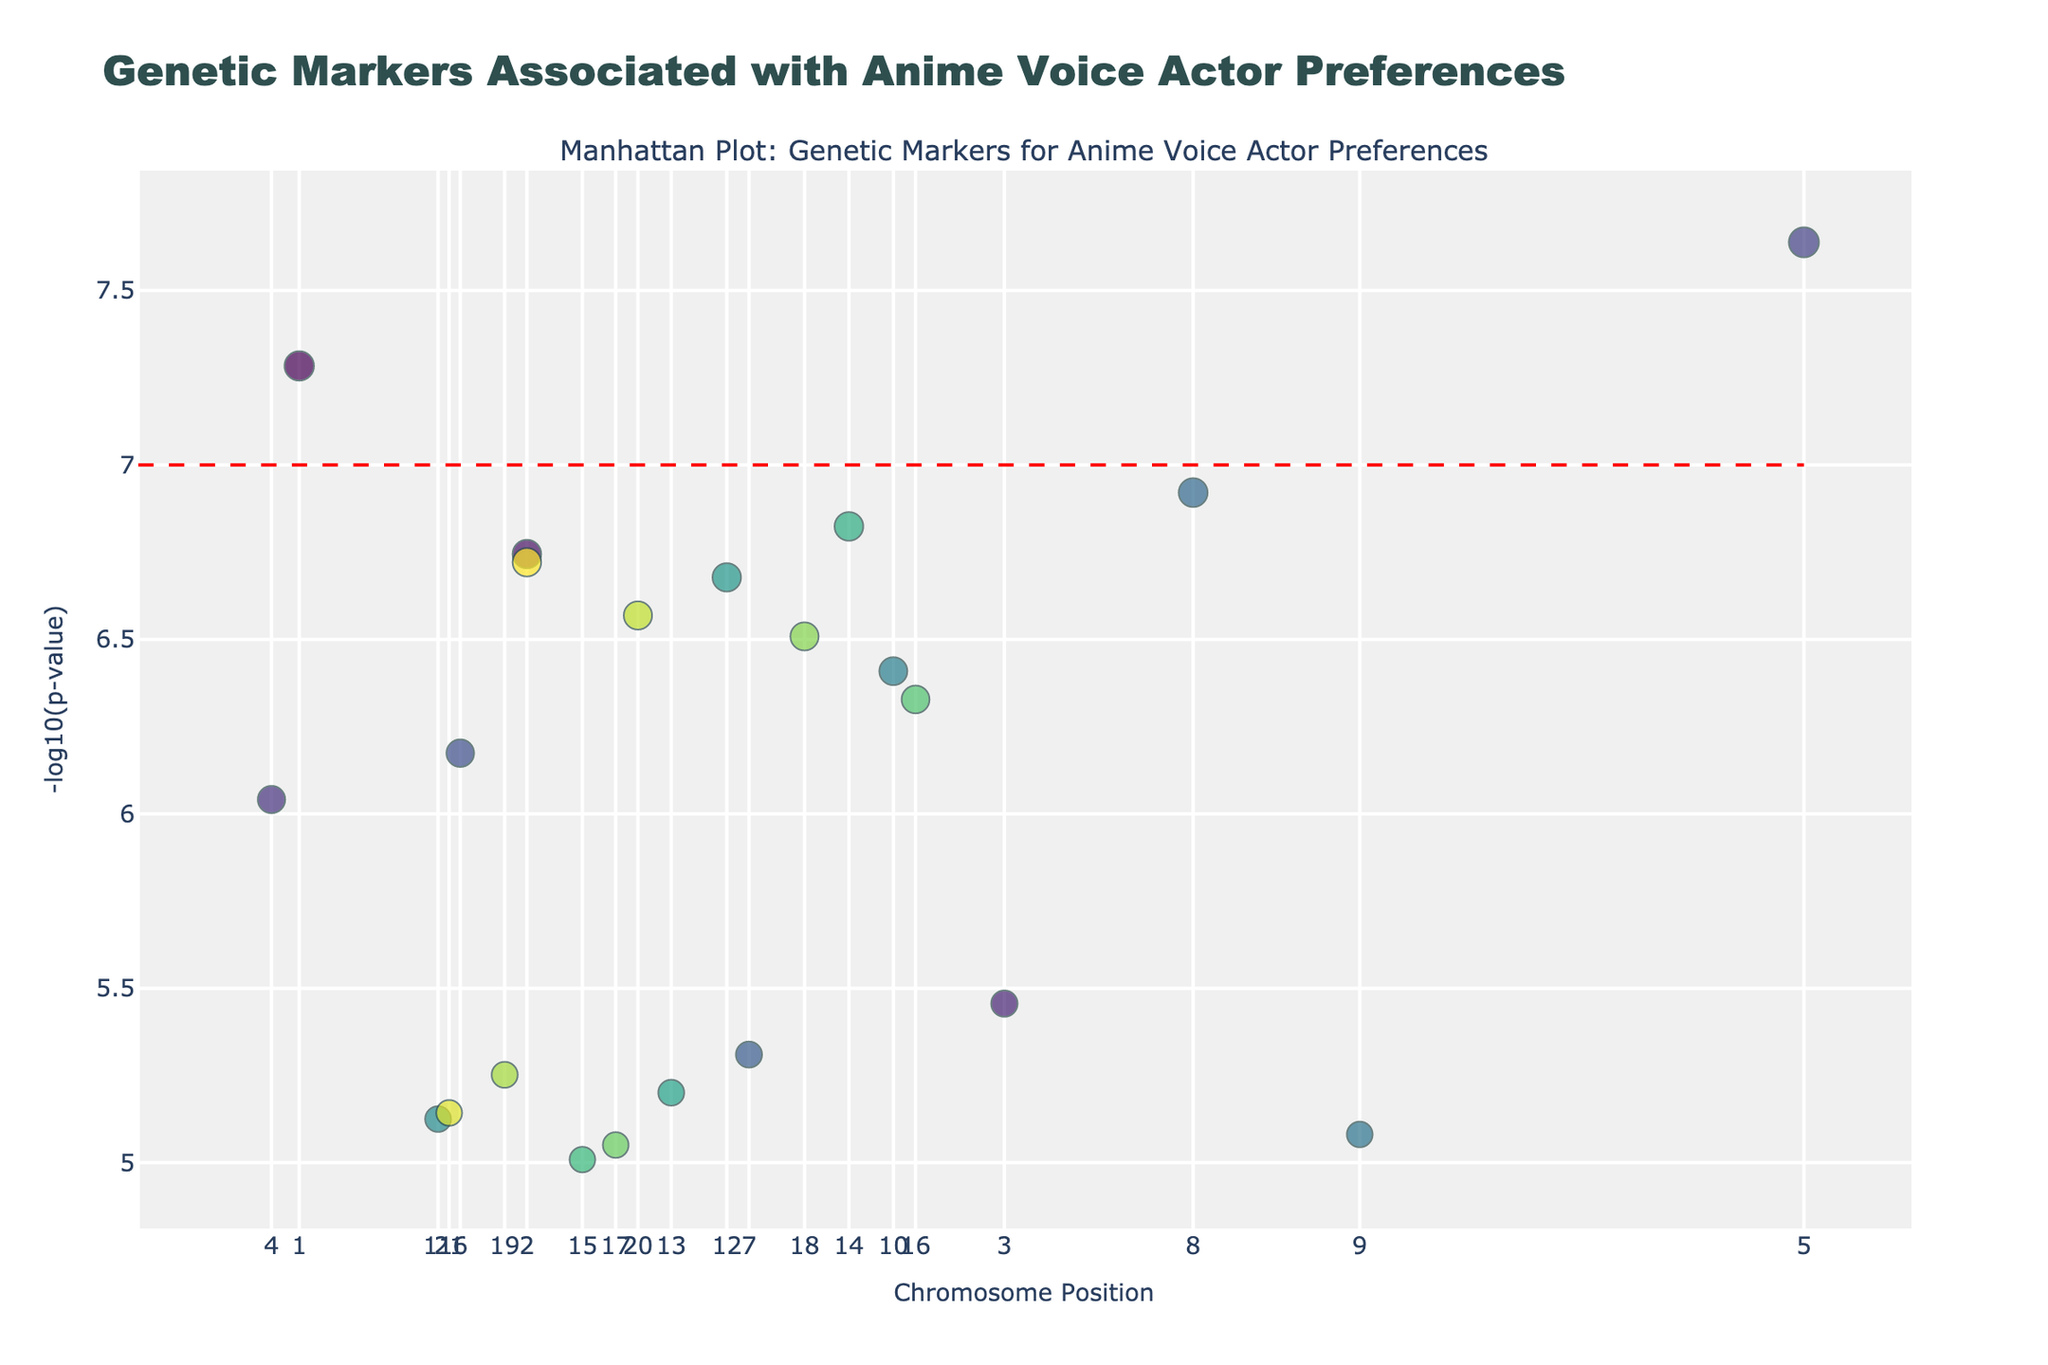What's the title of the Manhattan Plot? The title of the plot is located at the top center of the figure.
Answer: Genetic Markers Associated with Anime Voice Actor Preferences On which chromosome is the marker with the lowest p-value located? The chromosome can be identified by locating the highest point on the y-axis (which corresponds to the lowest p-value).
Answer: Chromosome 5 What is the y-axis measuring in this plot? The y-axis title indicates the metric being used.
Answer: -log10(p-value) How many genetic markers are significantly associated with Voice Actor preferences (p-value < 5e-8)? By counting the number of points above the horizontal threshold line (which is set at y = 7), we can determine the significant markers.
Answer: 2 Which gene is associated with Hiroshi Kamiya and has the lowest p-value? Identify the dots representing Hiroshi Kamiya's genes and find the one with the highest y-value.
Answer: COMT Are there more significant markers on the left or right side of the plot? Compare the number of markers above the threshold line on each side of the plot.
Answer: Left What is the position on the y-axis for the marker corresponding to the highest p-value? Identify the lowest point on the y-axis (least significant marker).
Answer: Approximately 5.38 For Voice Actor Kana Hanazawa, on which chromosomes do significant markers appear? Locate the points labeled with Kana Hanazawa and observe their chromosome numbers.
Answer: Chromosomes 1 and 20 Which voice actor has a significant marker on Chromosome 8? Identify the points on Chromosome 8 and find the voice actor associated with the significant marker.
Answer: Aya Hirano What's the average y-value of the significant markers for Rie Kugimiya? Extract the y-values for the markers associated with Rie Kugimiya and compute the average.
Answer: (−log10(1.8e-7) + −log10(7.2e-6)) / 2 ≈ 6.15 